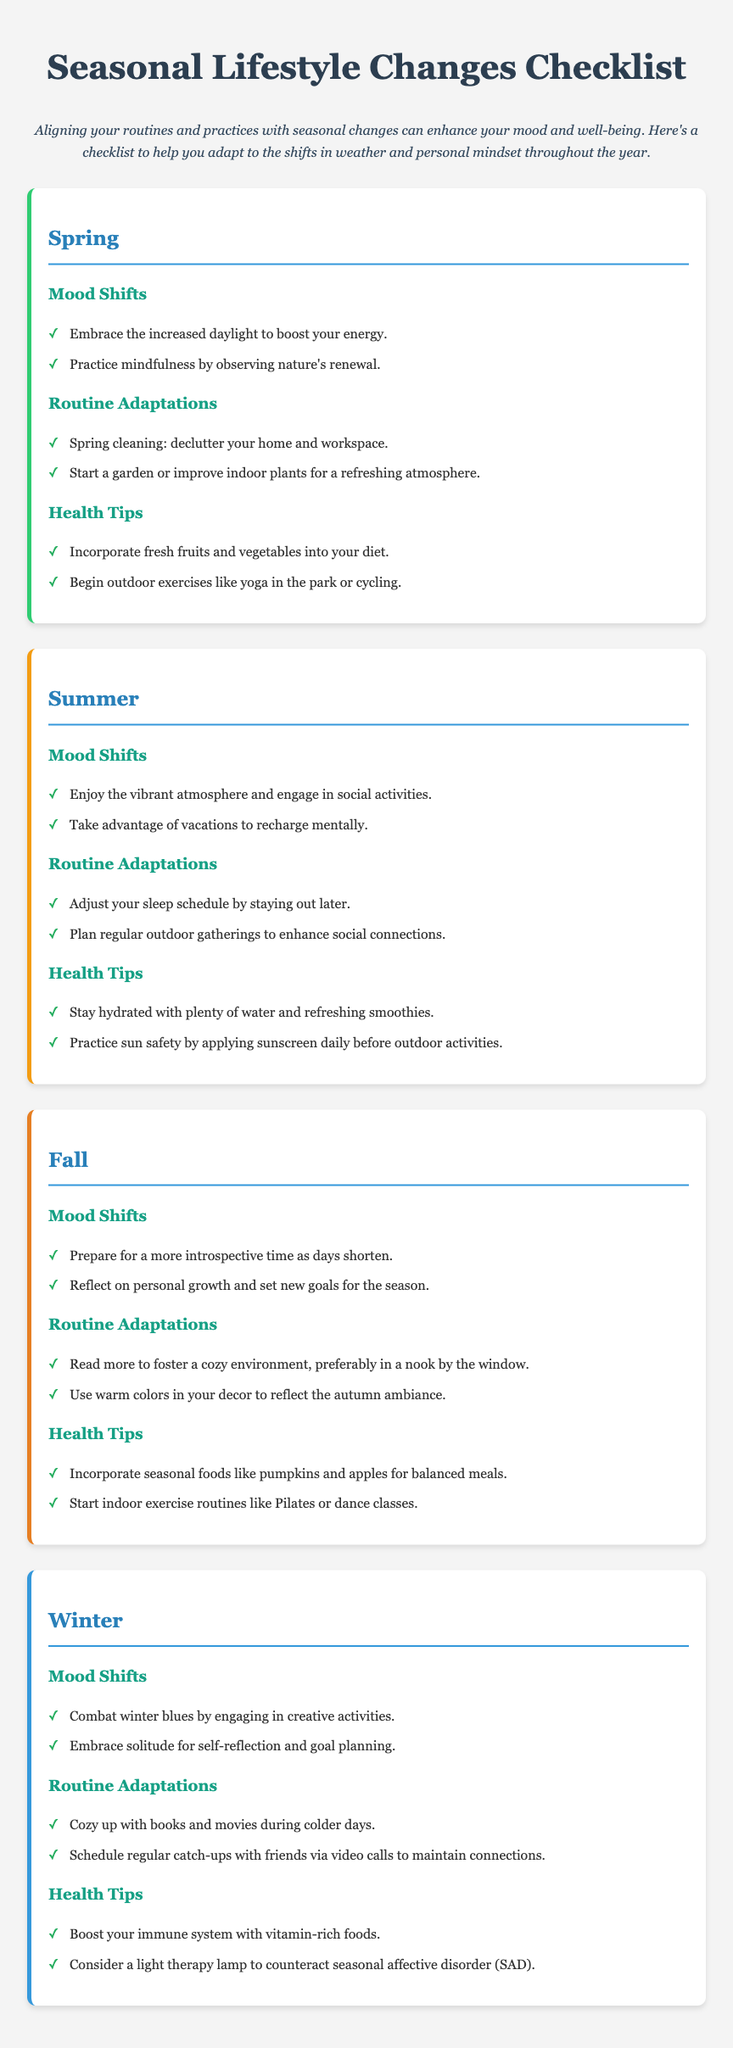What are two mood shifts suggested for Spring? The document lists the mood shifts for spring, which include embracing increased daylight to boost energy and practicing mindfulness by observing nature's renewal.
Answer: Increased daylight to boost energy, mindfulness by observing nature's renewal What is one health tip for Summer? The document provides health tips for summer, including staying hydrated with plenty of water and refreshing smoothies.
Answer: Stay hydrated with plenty of water and refreshing smoothies What activities are recommended for Winter to combat the blues? The document suggests engaging in creative activities and embracing solitude for self-reflection to combat winter blues.
Answer: Engaging in creative activities What seasonal foods are suggested for Fall? The health tips for fall indicate incorporating seasonal foods like pumpkins and apples for balanced meals.
Answer: Pumpkins and apples What is a routine adaptation for Summer? The routine adaptation for summer includes adjusting your sleep schedule by staying out later.
Answer: Adjust your sleep schedule by staying out later What colors should be used in Fall decor? The document mentions using warm colors in decor to reflect the autumn ambiance.
Answer: Warm colors What activity is recommended for Spring cleaning? According to the document, spring cleaning involves decluttering your home and workspace.
Answer: Declutter your home and workspace How does the document suggest to stay connected in Winter? The document recommends scheduling regular catch-ups with friends via video calls to maintain connections during winter.
Answer: Schedule regular catch-ups with friends via video calls 